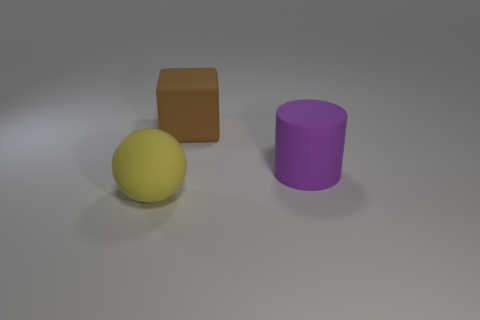What is the shape of the purple thing?
Ensure brevity in your answer.  Cylinder. There is a matte object in front of the large matte thing that is on the right side of the big brown block; how big is it?
Your response must be concise. Large. What number of things are either small yellow matte objects or large brown blocks?
Your response must be concise. 1. Is the shape of the large yellow object the same as the brown matte thing?
Give a very brief answer. No. Is there another large purple cylinder made of the same material as the large purple cylinder?
Your response must be concise. No. There is a big rubber thing behind the purple matte thing; are there any big rubber things in front of it?
Offer a terse response. Yes. The matte cylinder is what size?
Ensure brevity in your answer.  Large. Are there any rubber cylinders of the same color as the large cube?
Provide a short and direct response. No. What number of big things are yellow spheres or red metal cylinders?
Make the answer very short. 1. There is a block; how many brown objects are in front of it?
Offer a terse response. 0. 